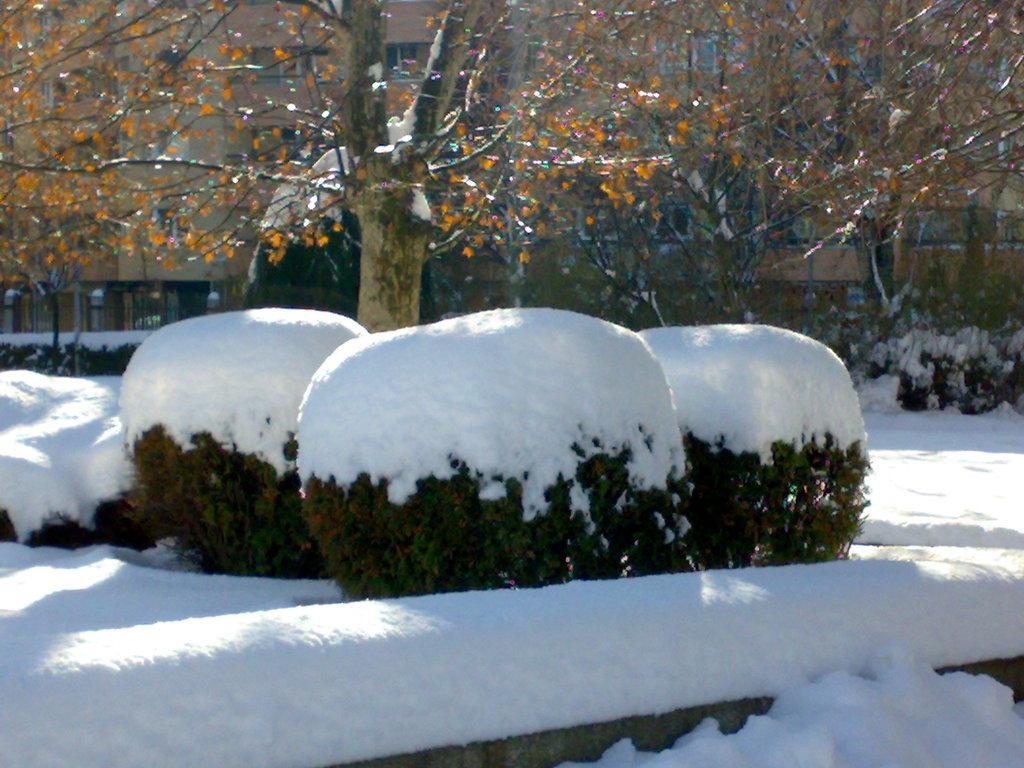What is the main subject of the image? There is a group of plants in the image. How are the plants in the image affected by the weather? The plants are covered in snow. What can be seen in the background of the image? There are trees and buildings in the background of the image. What type of throat soothing remedy can be seen in the image? There is no throat soothing remedy present in the image. Is there a farmer tending to the plants in the image? There is no farmer present in the image. 